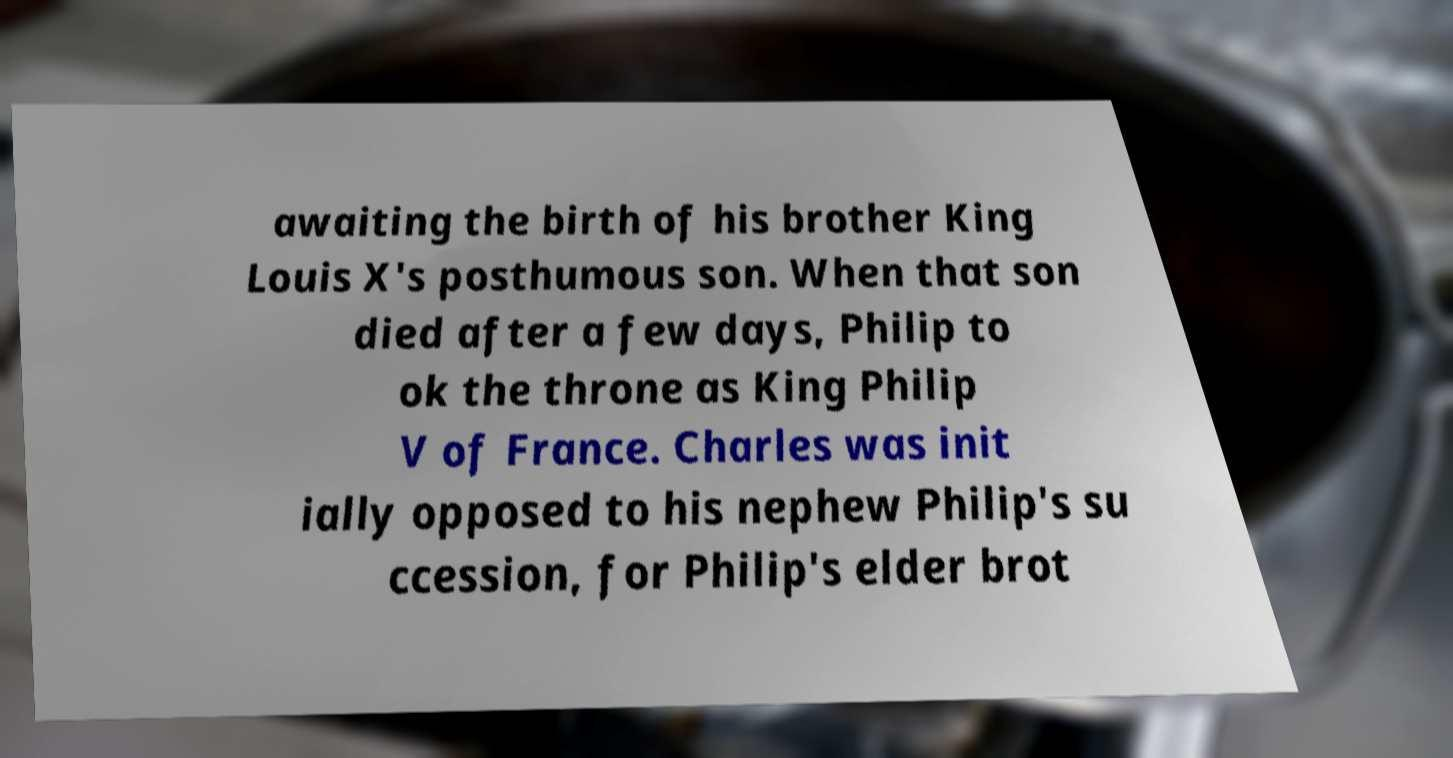What messages or text are displayed in this image? I need them in a readable, typed format. awaiting the birth of his brother King Louis X's posthumous son. When that son died after a few days, Philip to ok the throne as King Philip V of France. Charles was init ially opposed to his nephew Philip's su ccession, for Philip's elder brot 